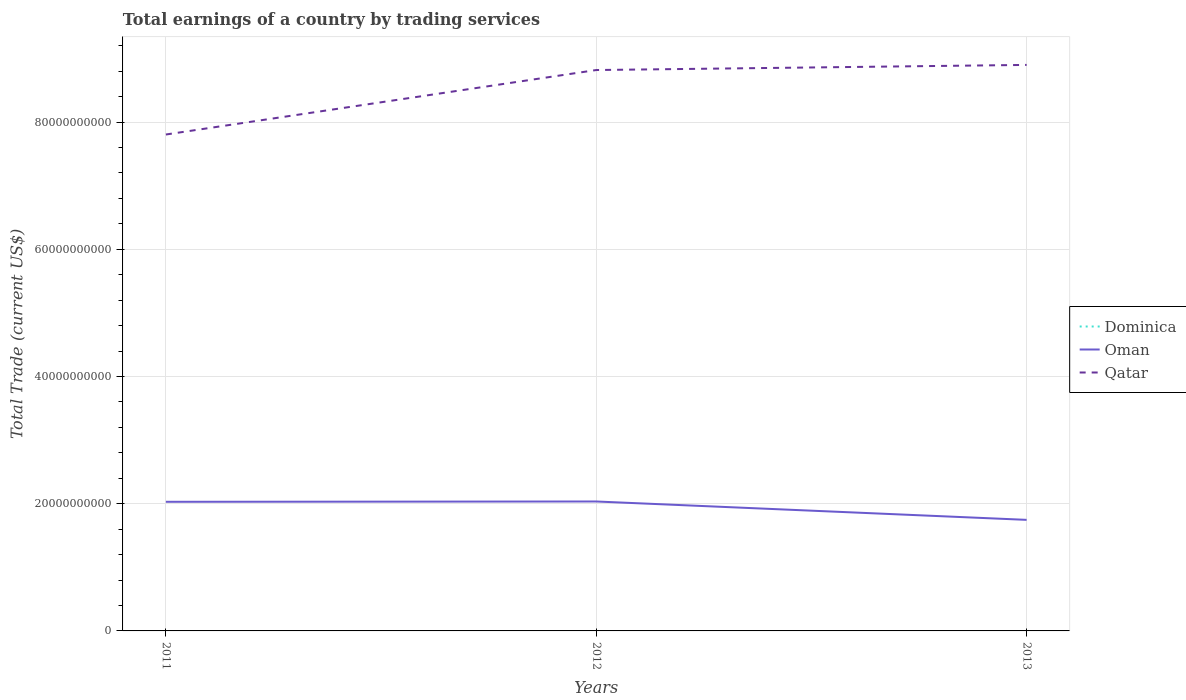Does the line corresponding to Dominica intersect with the line corresponding to Oman?
Keep it short and to the point. No. Is the number of lines equal to the number of legend labels?
Keep it short and to the point. No. Across all years, what is the maximum total earnings in Oman?
Give a very brief answer. 1.75e+1. What is the total total earnings in Oman in the graph?
Provide a succinct answer. 2.89e+09. What is the difference between the highest and the second highest total earnings in Qatar?
Make the answer very short. 1.09e+1. How many lines are there?
Provide a short and direct response. 2. How many years are there in the graph?
Provide a succinct answer. 3. What is the difference between two consecutive major ticks on the Y-axis?
Offer a terse response. 2.00e+1. Does the graph contain grids?
Keep it short and to the point. Yes. Where does the legend appear in the graph?
Your answer should be very brief. Center right. What is the title of the graph?
Keep it short and to the point. Total earnings of a country by trading services. What is the label or title of the Y-axis?
Give a very brief answer. Total Trade (current US$). What is the Total Trade (current US$) in Dominica in 2011?
Provide a short and direct response. 0. What is the Total Trade (current US$) in Oman in 2011?
Offer a terse response. 2.03e+1. What is the Total Trade (current US$) of Qatar in 2011?
Your answer should be very brief. 7.80e+1. What is the Total Trade (current US$) in Dominica in 2012?
Ensure brevity in your answer.  0. What is the Total Trade (current US$) in Oman in 2012?
Ensure brevity in your answer.  2.03e+1. What is the Total Trade (current US$) of Qatar in 2012?
Your answer should be very brief. 8.82e+1. What is the Total Trade (current US$) of Oman in 2013?
Make the answer very short. 1.75e+1. What is the Total Trade (current US$) of Qatar in 2013?
Ensure brevity in your answer.  8.90e+1. Across all years, what is the maximum Total Trade (current US$) of Oman?
Your response must be concise. 2.03e+1. Across all years, what is the maximum Total Trade (current US$) of Qatar?
Make the answer very short. 8.90e+1. Across all years, what is the minimum Total Trade (current US$) of Oman?
Give a very brief answer. 1.75e+1. Across all years, what is the minimum Total Trade (current US$) in Qatar?
Your answer should be compact. 7.80e+1. What is the total Total Trade (current US$) in Oman in the graph?
Your answer should be compact. 5.81e+1. What is the total Total Trade (current US$) in Qatar in the graph?
Provide a succinct answer. 2.55e+11. What is the difference between the Total Trade (current US$) in Oman in 2011 and that in 2012?
Offer a very short reply. -4.88e+07. What is the difference between the Total Trade (current US$) in Qatar in 2011 and that in 2012?
Your answer should be very brief. -1.01e+1. What is the difference between the Total Trade (current US$) of Oman in 2011 and that in 2013?
Your response must be concise. 2.84e+09. What is the difference between the Total Trade (current US$) in Qatar in 2011 and that in 2013?
Provide a succinct answer. -1.09e+1. What is the difference between the Total Trade (current US$) of Oman in 2012 and that in 2013?
Your response must be concise. 2.89e+09. What is the difference between the Total Trade (current US$) of Qatar in 2012 and that in 2013?
Provide a succinct answer. -8.06e+08. What is the difference between the Total Trade (current US$) in Oman in 2011 and the Total Trade (current US$) in Qatar in 2012?
Provide a short and direct response. -6.79e+1. What is the difference between the Total Trade (current US$) of Oman in 2011 and the Total Trade (current US$) of Qatar in 2013?
Your response must be concise. -6.87e+1. What is the difference between the Total Trade (current US$) of Oman in 2012 and the Total Trade (current US$) of Qatar in 2013?
Provide a succinct answer. -6.86e+1. What is the average Total Trade (current US$) in Dominica per year?
Offer a terse response. 0. What is the average Total Trade (current US$) in Oman per year?
Your answer should be compact. 1.94e+1. What is the average Total Trade (current US$) in Qatar per year?
Your answer should be compact. 8.51e+1. In the year 2011, what is the difference between the Total Trade (current US$) in Oman and Total Trade (current US$) in Qatar?
Make the answer very short. -5.77e+1. In the year 2012, what is the difference between the Total Trade (current US$) of Oman and Total Trade (current US$) of Qatar?
Offer a terse response. -6.78e+1. In the year 2013, what is the difference between the Total Trade (current US$) in Oman and Total Trade (current US$) in Qatar?
Your answer should be very brief. -7.15e+1. What is the ratio of the Total Trade (current US$) of Qatar in 2011 to that in 2012?
Offer a very short reply. 0.89. What is the ratio of the Total Trade (current US$) in Oman in 2011 to that in 2013?
Keep it short and to the point. 1.16. What is the ratio of the Total Trade (current US$) of Qatar in 2011 to that in 2013?
Provide a short and direct response. 0.88. What is the ratio of the Total Trade (current US$) of Oman in 2012 to that in 2013?
Your answer should be very brief. 1.17. What is the ratio of the Total Trade (current US$) in Qatar in 2012 to that in 2013?
Give a very brief answer. 0.99. What is the difference between the highest and the second highest Total Trade (current US$) of Oman?
Give a very brief answer. 4.88e+07. What is the difference between the highest and the second highest Total Trade (current US$) in Qatar?
Your answer should be very brief. 8.06e+08. What is the difference between the highest and the lowest Total Trade (current US$) of Oman?
Provide a short and direct response. 2.89e+09. What is the difference between the highest and the lowest Total Trade (current US$) in Qatar?
Make the answer very short. 1.09e+1. 